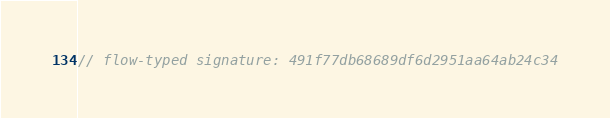<code> <loc_0><loc_0><loc_500><loc_500><_JavaScript_>// flow-typed signature: 491f77db68689df6d2951aa64ab24c34</code> 